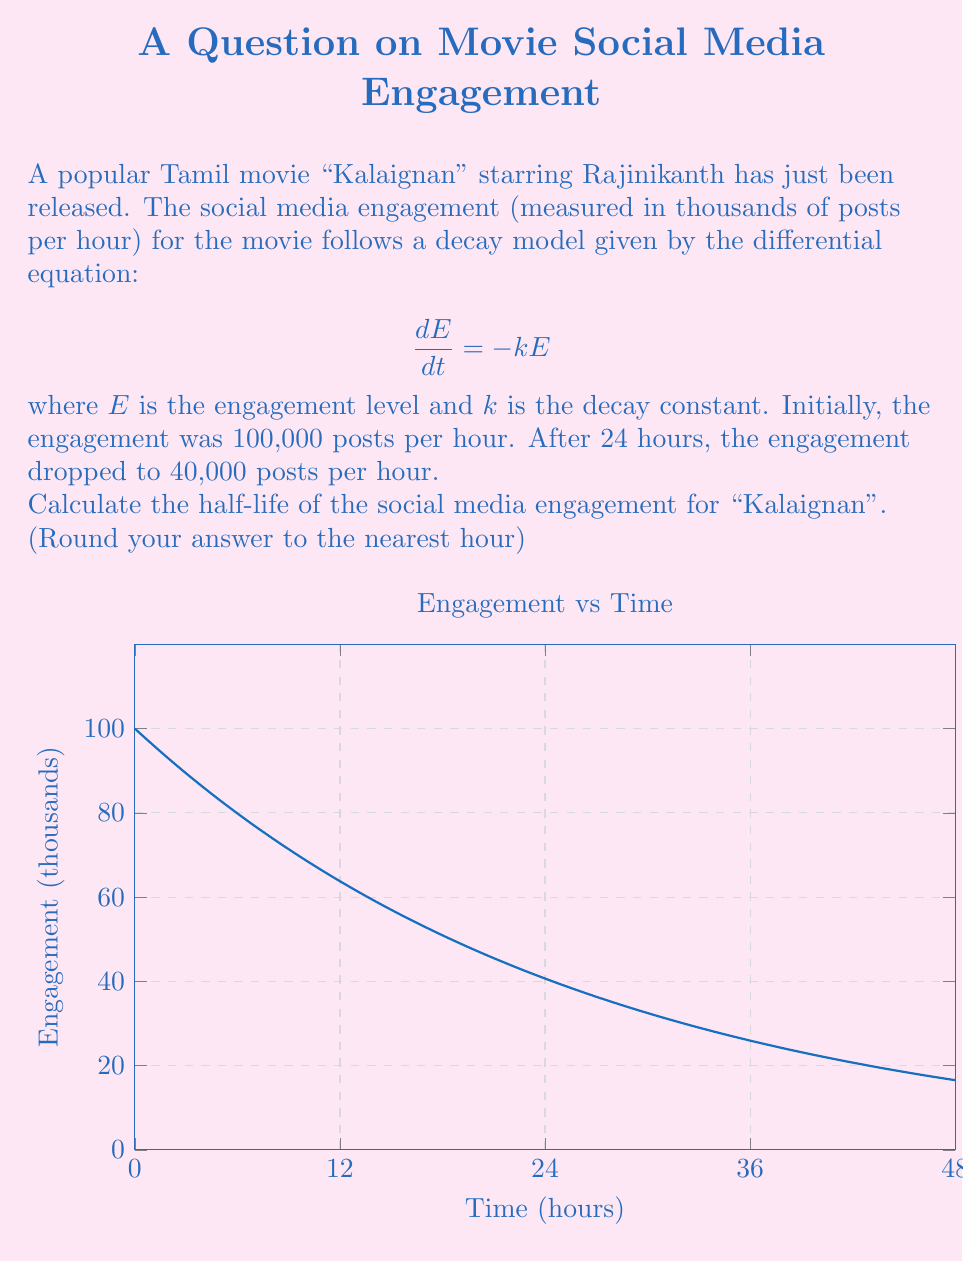Show me your answer to this math problem. Let's approach this step-by-step:

1) The general solution to the differential equation $\frac{dE}{dt} = -kE$ is:

   $E = E_0e^{-kt}$

   where $E_0$ is the initial engagement.

2) We're given that $E_0 = 100,000$ and after 24 hours, $E = 40,000$. Let's use these to find $k$:

   $40,000 = 100,000e^{-24k}$

3) Simplify:

   $0.4 = e^{-24k}$

4) Take natural log of both sides:

   $\ln(0.4) = -24k$

5) Solve for $k$:

   $k = -\frac{\ln(0.4)}{24} \approx 0.0375$

6) The half-life $t_{1/2}$ is the time it takes for the engagement to reduce to half its value. It satisfies:

   $0.5 = e^{-kt_{1/2}}$

7) Take natural log of both sides:

   $\ln(0.5) = -kt_{1/2}$

8) Solve for $t_{1/2}$:

   $t_{1/2} = -\frac{\ln(0.5)}{k} = \frac{\ln(2)}{k} \approx \frac{0.693}{0.0375} \approx 18.48$ hours

9) Rounding to the nearest hour:

   $t_{1/2} \approx 18$ hours
Answer: 18 hours 